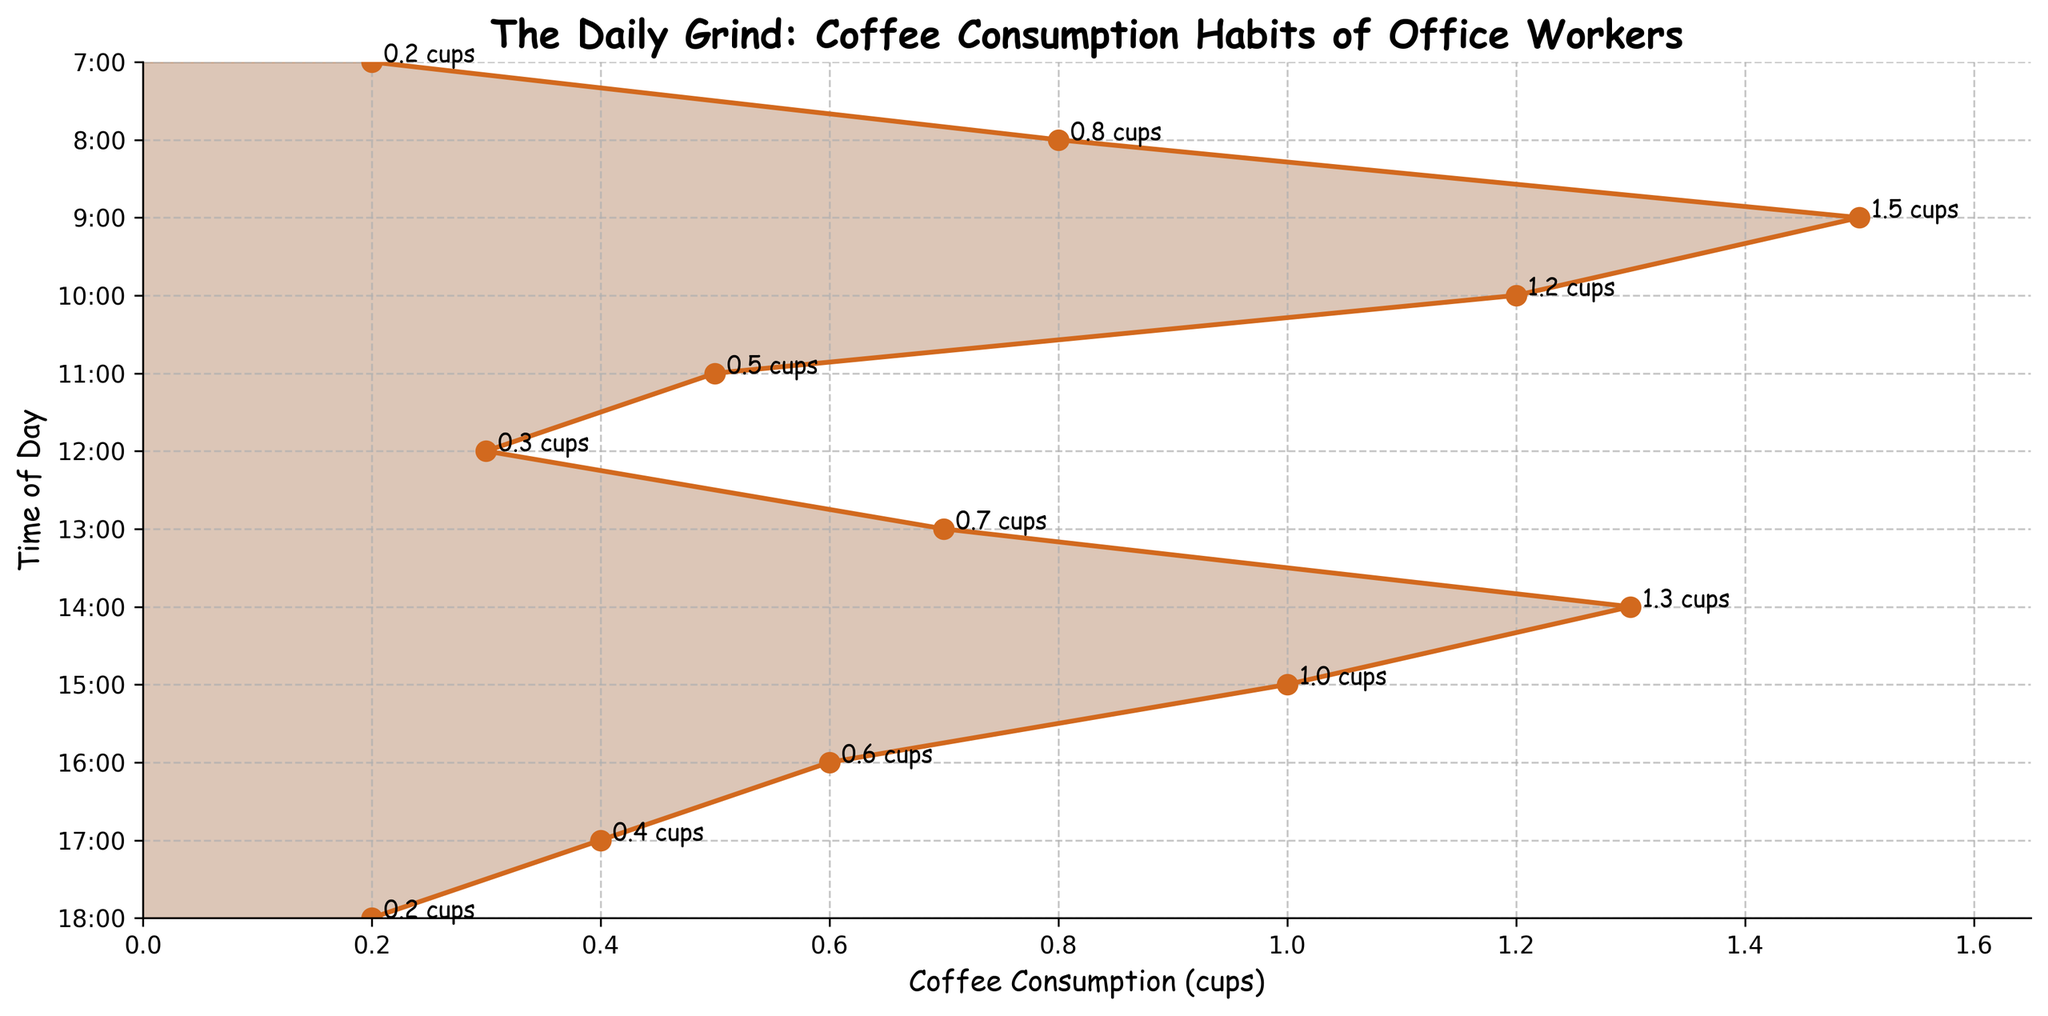What is the title of the figure? The title is written prominently at the top of the figure.
Answer: The Daily Grind: Coffee Consumption Habits of Office Workers What does the x-axis measure? The x-axis measures coffee consumption in cups, as indicated by the x-axis label at the bottom of the figure.
Answer: Coffee consumption (cups) At what time is coffee consumption the highest? By looking at the plot, the peak is where the line reaches its maximum height, which happens at 9:00.
Answer: 9:00 How many cups of coffee are consumed at 9:00? The annotation for the 9:00 point shows the consumption directly on the plot.
Answer: 1.5 cups What is the lowest time-of-day coffee consumption value shown? The smallest value on the x-axis that intersects with the time markers indicates the least consumption. This occurs at two points, 7:00 and 18:00.
Answer: 0.2 How does coffee consumption at 10:00 compare to that at 14:00? The plot shows the values directly: 1.2 cups at 10:00 and 1.3 cups at 14:00. We can see that the consumption at 14:00 is slightly higher.
Answer: 14:00 has higher consumption What is the average coffee consumption between 7:00 and 12:00? Add the consumption values from 7:00 to 12:00 and divide by the number of time points: (0.2 + 0.8 + 1.5 + 1.2 + 0.5 + 0.3) / 6 = 4.5 / 6 = 0.75 cups.
Answer: 0.75 cups Which time period experiences a drop in coffee consumption right after a peak? Consumption peaks at 9:00 with 1.5 cups, followed by a drop to 1.2 cups at 10:00.
Answer: 9:00 to 10:00 Are there more periods where coffee consumption increases or decreases throughout the day? By visually scanning the plot, count the segments where the consumption increases then compare them to where it decreases. There are 5 increases (7:00-8:00, 8:00-9:00, 12:00-13:00, 13:00-14:00, 15:00-16:00) and 6 decreases (9:00-10:00, 10:00-11:00, 11:00-12:00, 14:00-15:00, 16:00-17:00, 17:00-18:00).
Answer: More decreases What is the total number of coffee consumption points shown in the figure? Count the number of time vs consumption pairs shown on the plot.
Answer: 12 points 